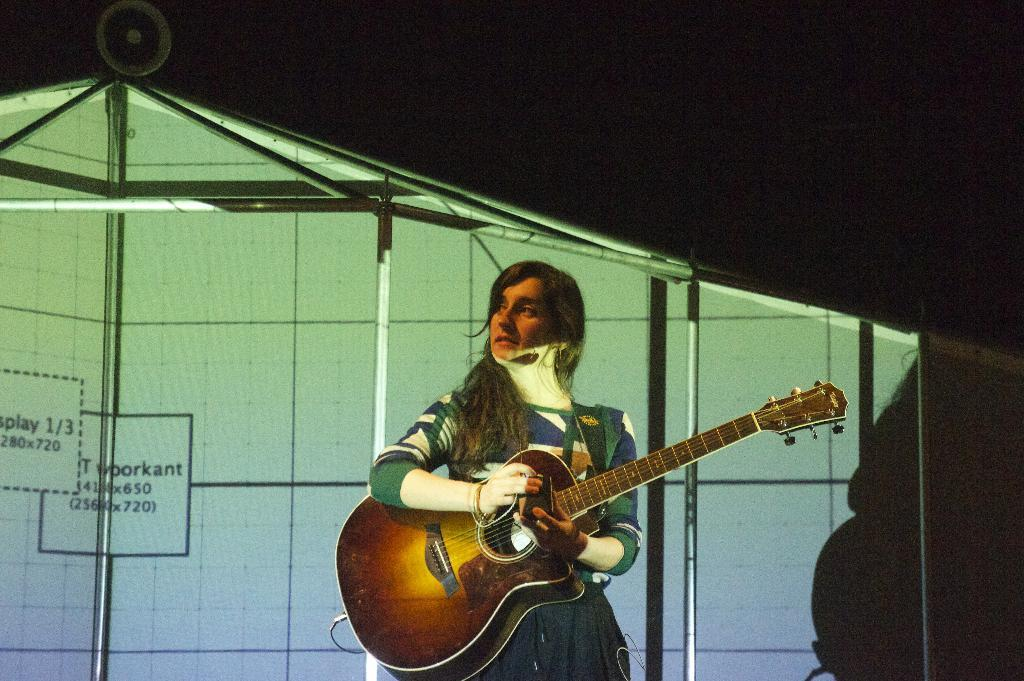What is the main subject of the image? The main subject of the image is a woman. What is the woman doing in the image? The woman is playing a guitar in the image. How many babies are being held by the woman's aunt in the image? There is no mention of an aunt or babies in the image; it only features a woman playing a guitar. 